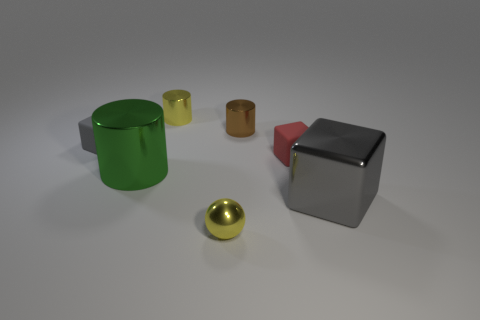There is a brown cylinder that is the same size as the red rubber thing; what material is it?
Give a very brief answer. Metal. Is the number of tiny things in front of the green shiny cylinder less than the number of tiny shiny cylinders that are to the left of the red cube?
Offer a very short reply. Yes. There is a rubber object that is right of the object that is in front of the big gray block; what is its shape?
Make the answer very short. Cube. Are any tiny brown rubber blocks visible?
Give a very brief answer. No. What color is the metal thing that is to the right of the tiny brown cylinder?
Provide a short and direct response. Gray. What material is the other cube that is the same color as the big block?
Give a very brief answer. Rubber. Are there any big cylinders behind the tiny red matte thing?
Provide a succinct answer. No. Are there more rubber blocks than big shiny cylinders?
Offer a very short reply. Yes. What is the color of the cylinder that is in front of the rubber thing that is behind the small matte object that is on the right side of the yellow cylinder?
Your answer should be very brief. Green. The large cube that is the same material as the yellow ball is what color?
Give a very brief answer. Gray. 